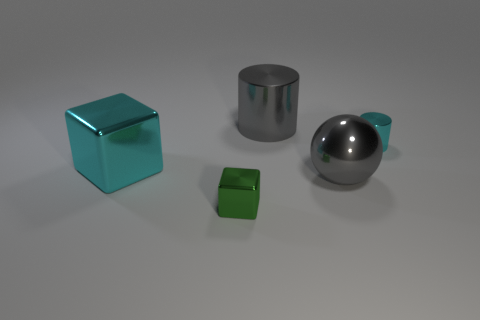Add 3 gray metallic things. How many objects exist? 8 Subtract all spheres. How many objects are left? 4 Add 3 tiny cyan objects. How many tiny cyan objects exist? 4 Subtract 0 yellow blocks. How many objects are left? 5 Subtract all gray matte cylinders. Subtract all tiny green objects. How many objects are left? 4 Add 3 gray cylinders. How many gray cylinders are left? 4 